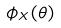<formula> <loc_0><loc_0><loc_500><loc_500>\phi _ { X } ( \theta )</formula> 